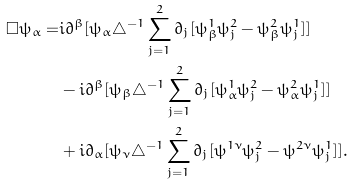<formula> <loc_0><loc_0><loc_500><loc_500>\Box \psi _ { \alpha } = & i \partial ^ { \beta } [ \psi _ { \alpha } \triangle ^ { - 1 } \sum _ { j = 1 } ^ { 2 } \partial _ { j } [ \psi ^ { 1 } _ { \beta } \psi ^ { 2 } _ { j } - \psi ^ { 2 } _ { \beta } \psi ^ { 1 } _ { j } ] ] \\ & - i \partial ^ { \beta } [ \psi _ { \beta } \triangle ^ { - 1 } \sum _ { j = 1 } ^ { 2 } \partial _ { j } [ \psi ^ { 1 } _ { \alpha } \psi ^ { 2 } _ { j } - \psi ^ { 2 } _ { \alpha } \psi ^ { 1 } _ { j } ] ] \\ & + i \partial _ { \alpha } [ \psi _ { \nu } \triangle ^ { - 1 } \sum _ { j = 1 } ^ { 2 } \partial _ { j } [ \psi ^ { 1 \nu } \psi ^ { 2 } _ { j } - \psi ^ { 2 \nu } \psi ^ { 1 } _ { j } ] ] . \\</formula> 